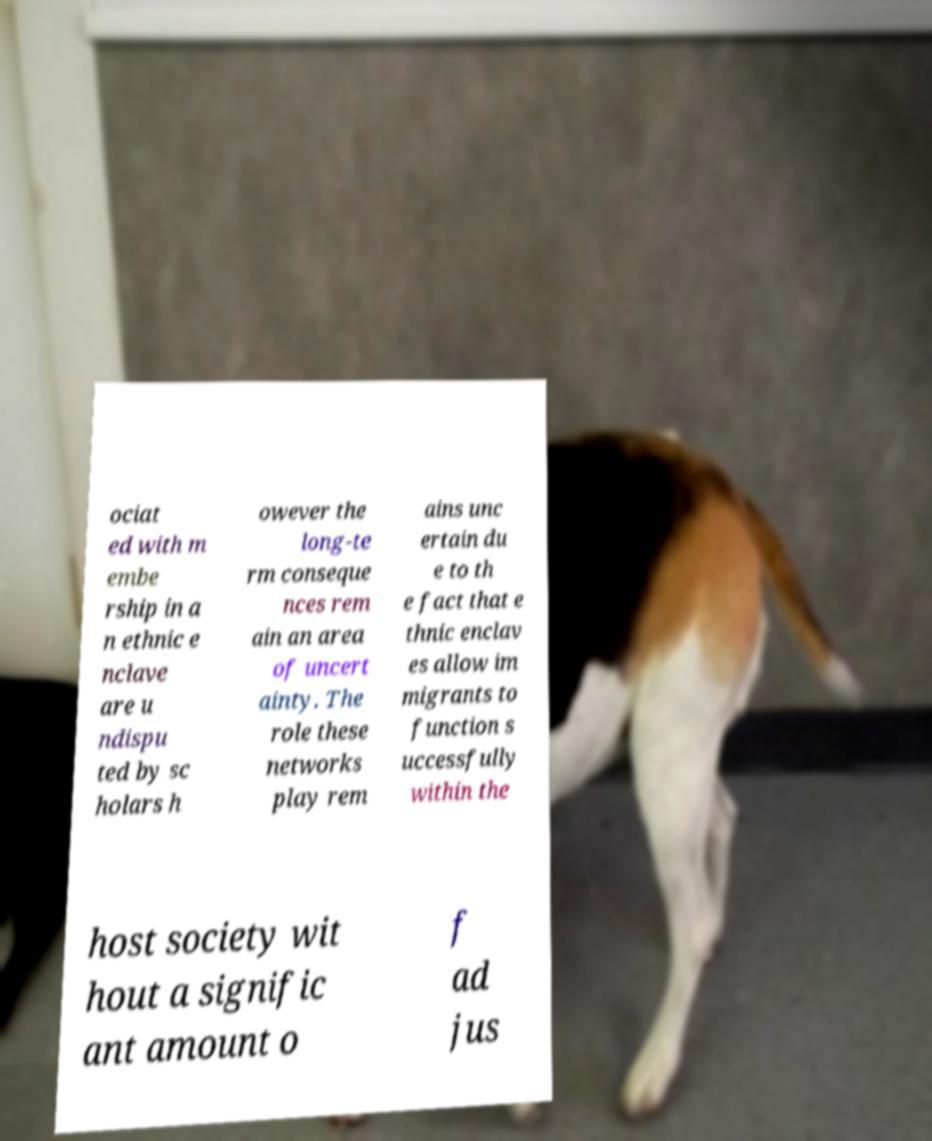Please read and relay the text visible in this image. What does it say? ociat ed with m embe rship in a n ethnic e nclave are u ndispu ted by sc holars h owever the long-te rm conseque nces rem ain an area of uncert ainty. The role these networks play rem ains unc ertain du e to th e fact that e thnic enclav es allow im migrants to function s uccessfully within the host society wit hout a signific ant amount o f ad jus 